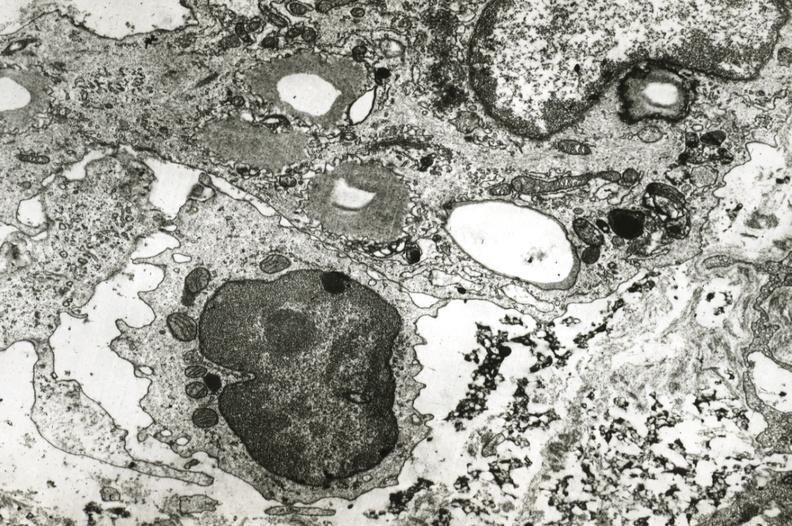what is present?
Answer the question using a single word or phrase. Cardiovascular 